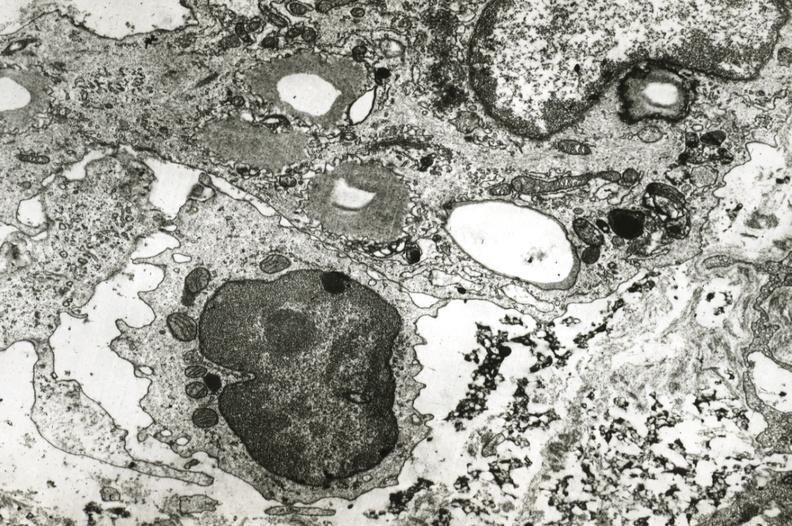what is present?
Answer the question using a single word or phrase. Cardiovascular 